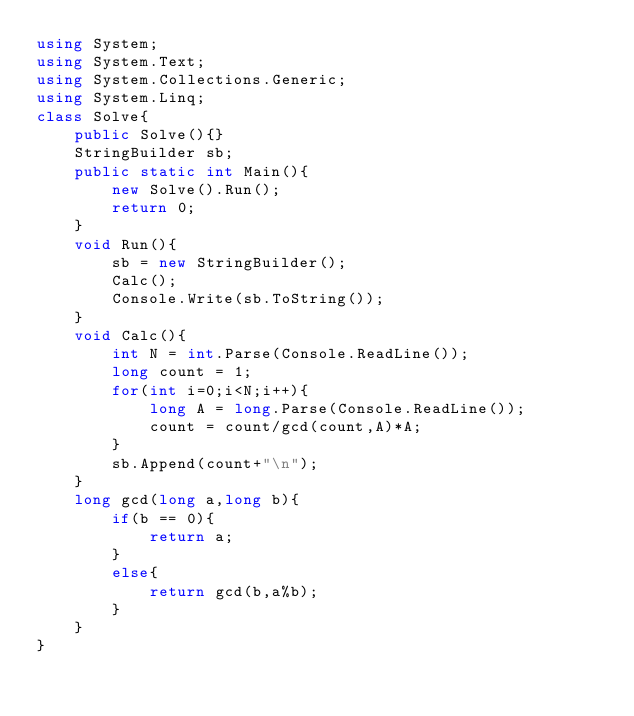<code> <loc_0><loc_0><loc_500><loc_500><_C#_>using System;
using System.Text;
using System.Collections.Generic;
using System.Linq;
class Solve{
    public Solve(){}
    StringBuilder sb;
    public static int Main(){
        new Solve().Run();
        return 0;
    }
    void Run(){
        sb = new StringBuilder();
        Calc();
        Console.Write(sb.ToString());
    }
    void Calc(){
        int N = int.Parse(Console.ReadLine());
        long count = 1;
        for(int i=0;i<N;i++){
            long A = long.Parse(Console.ReadLine());
            count = count/gcd(count,A)*A;
        }
        sb.Append(count+"\n");
    }
    long gcd(long a,long b){
        if(b == 0){
            return a;
        }
        else{
            return gcd(b,a%b);
        }
    }
}</code> 